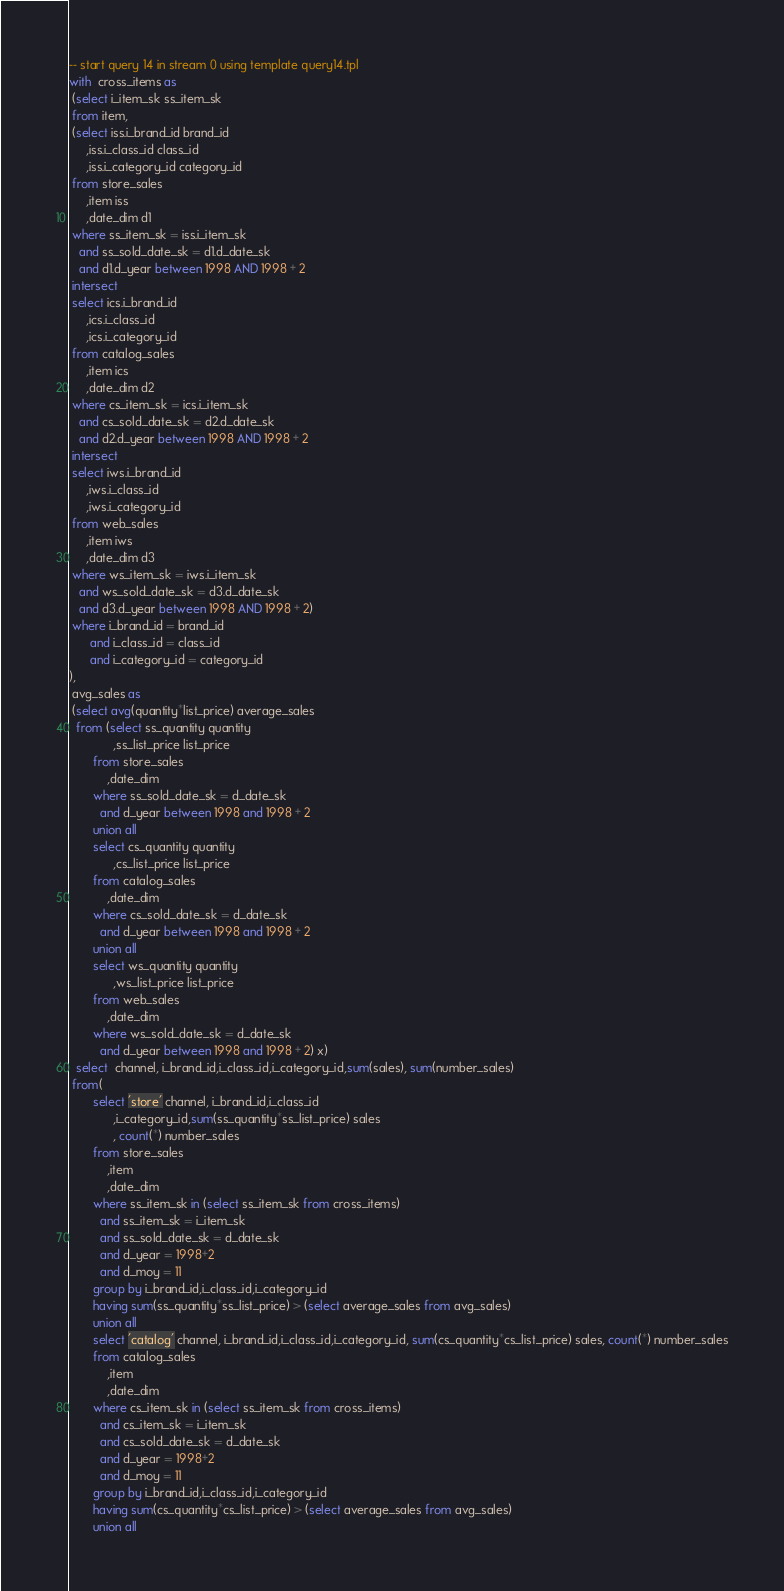<code> <loc_0><loc_0><loc_500><loc_500><_SQL_>-- start query 14 in stream 0 using template query14.tpl
with  cross_items as
 (select i_item_sk ss_item_sk
 from item,
 (select iss.i_brand_id brand_id
     ,iss.i_class_id class_id
     ,iss.i_category_id category_id
 from store_sales
     ,item iss
     ,date_dim d1
 where ss_item_sk = iss.i_item_sk
   and ss_sold_date_sk = d1.d_date_sk
   and d1.d_year between 1998 AND 1998 + 2
 intersect
 select ics.i_brand_id
     ,ics.i_class_id
     ,ics.i_category_id
 from catalog_sales
     ,item ics
     ,date_dim d2
 where cs_item_sk = ics.i_item_sk
   and cs_sold_date_sk = d2.d_date_sk
   and d2.d_year between 1998 AND 1998 + 2
 intersect
 select iws.i_brand_id
     ,iws.i_class_id
     ,iws.i_category_id
 from web_sales
     ,item iws
     ,date_dim d3
 where ws_item_sk = iws.i_item_sk
   and ws_sold_date_sk = d3.d_date_sk
   and d3.d_year between 1998 AND 1998 + 2)
 where i_brand_id = brand_id
      and i_class_id = class_id
      and i_category_id = category_id
),
 avg_sales as
 (select avg(quantity*list_price) average_sales
  from (select ss_quantity quantity
             ,ss_list_price list_price
       from store_sales
           ,date_dim
       where ss_sold_date_sk = d_date_sk
         and d_year between 1998 and 1998 + 2
       union all
       select cs_quantity quantity
             ,cs_list_price list_price
       from catalog_sales
           ,date_dim
       where cs_sold_date_sk = d_date_sk
         and d_year between 1998 and 1998 + 2
       union all
       select ws_quantity quantity
             ,ws_list_price list_price
       from web_sales
           ,date_dim
       where ws_sold_date_sk = d_date_sk
         and d_year between 1998 and 1998 + 2) x)
  select  channel, i_brand_id,i_class_id,i_category_id,sum(sales), sum(number_sales)
 from(
       select 'store' channel, i_brand_id,i_class_id
             ,i_category_id,sum(ss_quantity*ss_list_price) sales
             , count(*) number_sales
       from store_sales
           ,item
           ,date_dim
       where ss_item_sk in (select ss_item_sk from cross_items)
         and ss_item_sk = i_item_sk
         and ss_sold_date_sk = d_date_sk
         and d_year = 1998+2
         and d_moy = 11
       group by i_brand_id,i_class_id,i_category_id
       having sum(ss_quantity*ss_list_price) > (select average_sales from avg_sales)
       union all
       select 'catalog' channel, i_brand_id,i_class_id,i_category_id, sum(cs_quantity*cs_list_price) sales, count(*) number_sales
       from catalog_sales
           ,item
           ,date_dim
       where cs_item_sk in (select ss_item_sk from cross_items)
         and cs_item_sk = i_item_sk
         and cs_sold_date_sk = d_date_sk
         and d_year = 1998+2
         and d_moy = 11
       group by i_brand_id,i_class_id,i_category_id
       having sum(cs_quantity*cs_list_price) > (select average_sales from avg_sales)
       union all</code> 